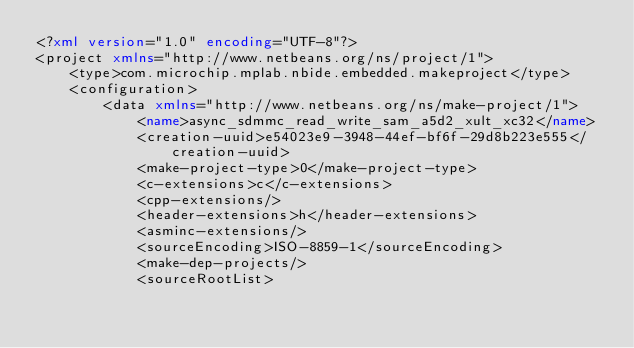Convert code to text. <code><loc_0><loc_0><loc_500><loc_500><_XML_><?xml version="1.0" encoding="UTF-8"?>
<project xmlns="http://www.netbeans.org/ns/project/1">
    <type>com.microchip.mplab.nbide.embedded.makeproject</type>
    <configuration>
        <data xmlns="http://www.netbeans.org/ns/make-project/1">
            <name>async_sdmmc_read_write_sam_a5d2_xult_xc32</name>
            <creation-uuid>e54023e9-3948-44ef-bf6f-29d8b223e555</creation-uuid>
            <make-project-type>0</make-project-type>
            <c-extensions>c</c-extensions>
            <cpp-extensions/>
            <header-extensions>h</header-extensions>
            <asminc-extensions/>
            <sourceEncoding>ISO-8859-1</sourceEncoding>
            <make-dep-projects/>
            <sourceRootList></code> 